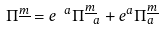<formula> <loc_0><loc_0><loc_500><loc_500>\Pi ^ { \underline { m } } = e ^ { \ a } \Pi _ { \ a } ^ { \underline { m } } + e ^ { a } \Pi _ { a } ^ { \underline { m } }</formula> 